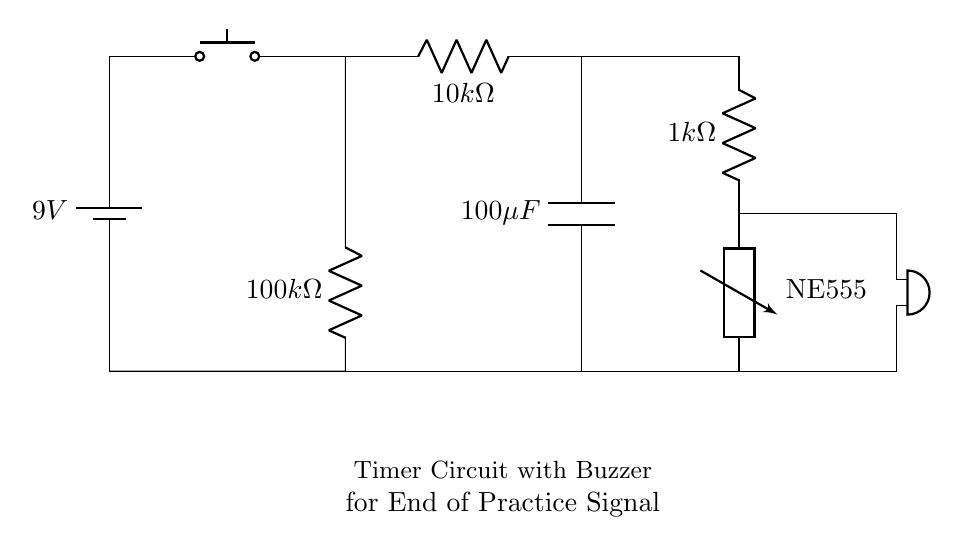What is the voltage source used in the circuit? The circuit uses a 9V battery as its power source, which is indicated by the battery symbol labeled with the voltage value.
Answer: 9V What is the resistance value of R1? R1 is labeled with the symbol for resistance and indicates a value of 10k ohms, which is specified in the circuit diagram.
Answer: 10k ohms What component acts as the timer in this circuit? The NE555 timer is represented in the circuit diagram by its labeled symbol, indicating that it is the component responsible for timing functions.
Answer: NE555 How many resistors are in the circuit? The circuit diagram contains three resistors, R1, R2, and R3, each labeled with their respective values.
Answer: 3 What is the capacitance value of the capacitor? The capacitor in the diagram is labeled C1 with a capacitance value of 100 microfarads, as indicated in the circuit diagram.
Answer: 100 microfarads What happens when the push button is pressed? Pressing the push button completes the circuit, allowing current to flow through the timer and triggering the buzzer to sound, signaling the end of practice.
Answer: The buzzer sounds 